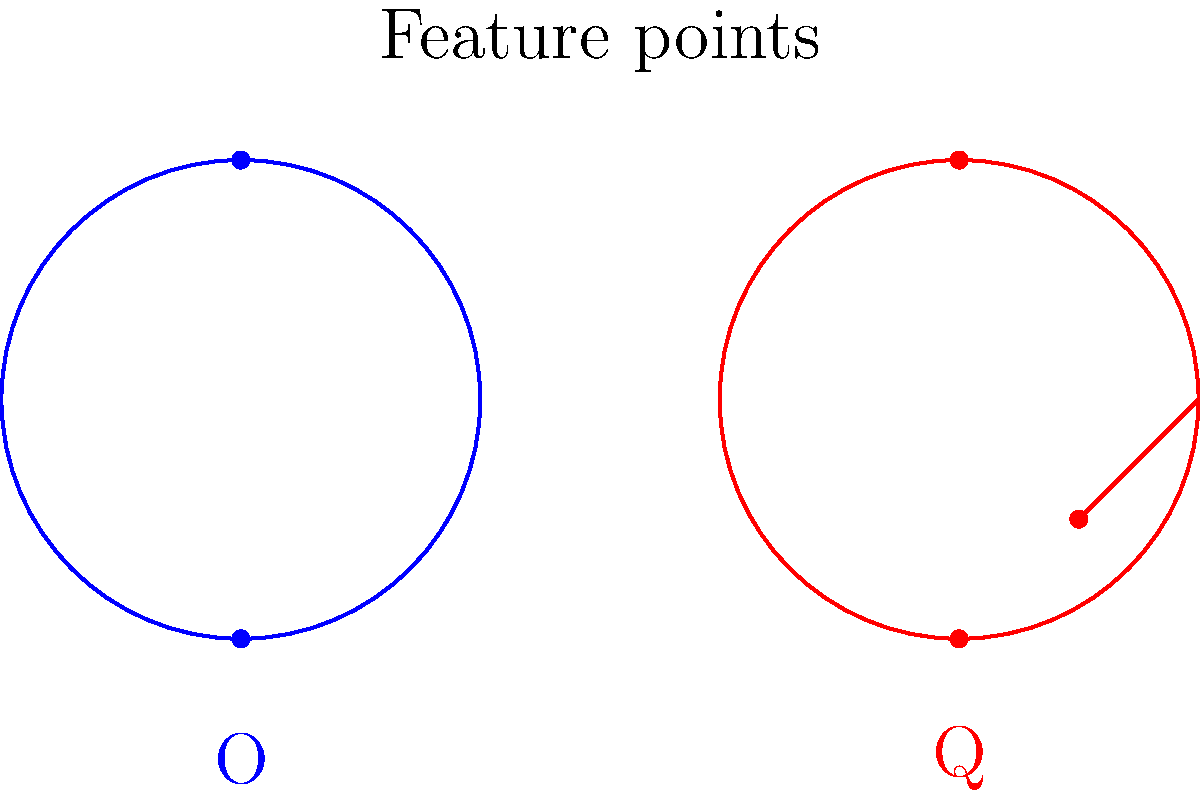In distinguishing between similar characters like 'O' and 'Q', which feature extraction technique would be most effective for capturing the subtle differences, and why? To distinguish between similar characters like 'O' and 'Q', we need to consider several feature extraction techniques:

1. Contour Analysis:
   - Examines the outer shape of characters
   - Effective for capturing the overall form, but may miss subtle differences

2. Skeleton Extraction:
   - Reduces characters to their central lines
   - Useful for general shape, but may not capture the tail of 'Q'

3. Zoning:
   - Divides the character into regions and analyzes each separately
   - Can detect the presence of the tail in 'Q', but may lack precision

4. Gradient Features:
   - Captures direction and magnitude of intensity changes
   - Sensitive to subtle curves and lines, including the 'Q' tail

5. Corner Detection:
   - Identifies sharp changes in contour direction
   - Highly effective for detecting the distinctive tail of 'Q'

6. Histogram of Oriented Gradients (HOG):
   - Computes gradient orientation histograms in local regions
   - Captures both overall shape and local details like the 'Q' tail

Among these, the Histogram of Oriented Gradients (HOG) would be most effective because:

a) It captures both global shape and local details
b) It's robust to small geometric transformations
c) It can distinguish the subtle difference of the 'Q' tail
d) It provides a rich feature representation for machine learning algorithms

HOG divides the image into small cells, computes gradient orientations for each pixel, and creates histograms for each cell. This approach allows it to capture the circular shape common to both 'O' and 'Q', while also detecting the distinctive tail of 'Q' in the relevant cells.
Answer: Histogram of Oriented Gradients (HOG) 